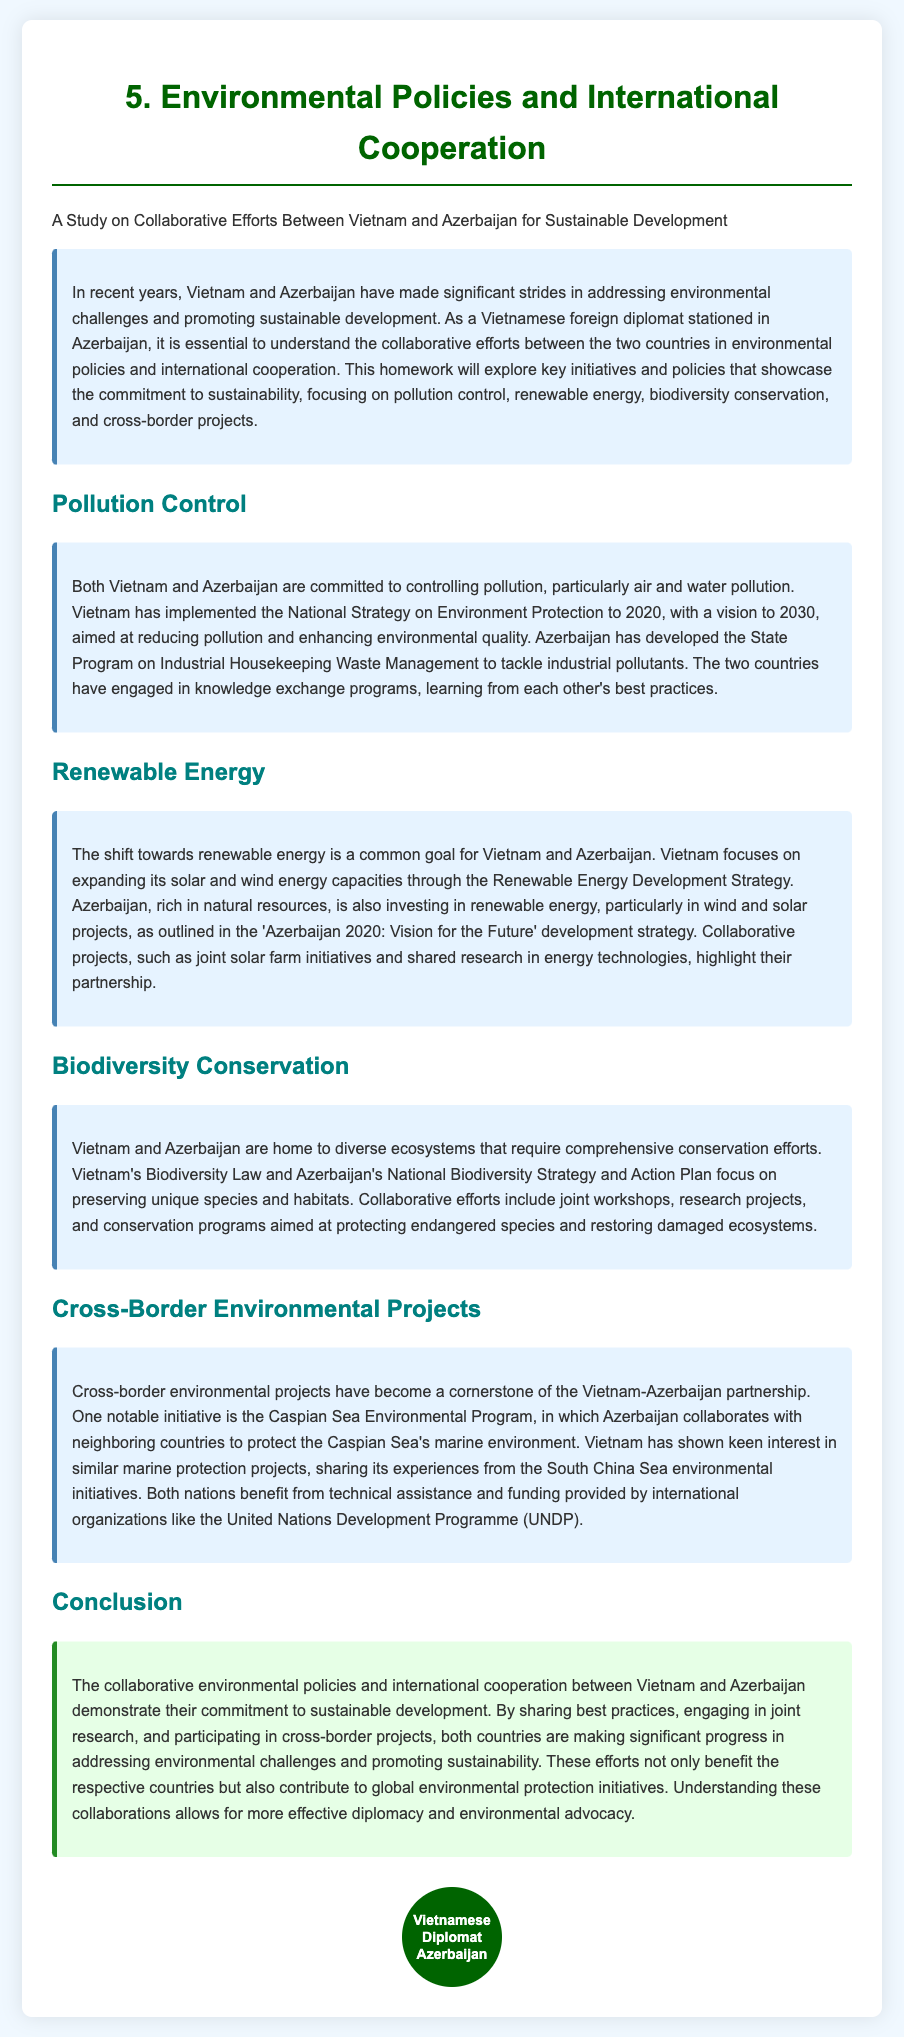What is the title of the study? The title of the study is indicated in the document header, highlighting the main focus.
Answer: Environmental Policies and International Cooperation What are the main pollutants addressed in the document? The document specifies that both countries focus on air and water pollution control.
Answer: Air and water pollution What is the vision year for Vietnam's National Strategy on Environment Protection? The document states the vision year for this strategy as 2030.
Answer: 2030 Which renewable energy sources are mentioned for Vietnam? The document lists solar and wind energy capacities as the focus areas.
Answer: Solar and wind What program is Azerbaijan developing for industrial waste? The document refers to the State Program on Industrial Housekeeping Waste Management.
Answer: State Program on Industrial Housekeeping Waste Management What strategy does Azerbaijan’s environmental policy align with? The document mentions the 'Azerbaijan 2020: Vision for the Future' as the guiding strategy.
Answer: Azerbaijan 2020: Vision for the Future Which international organization provides funding for environmental projects? The document indicates that the United Nations Development Programme (UNDP) is involved in funding.
Answer: United Nations Development Programme What is one of the joint initiatives between Vietnam and Azerbaijan? The document highlights the Caspian Sea Environmental Program as a notable initiative.
Answer: Caspian Sea Environmental Program What does Vietnam's Biodiversity Law aim to protect? The document states that the law focuses on preserving unique species and habitats.
Answer: Unique species and habitats 